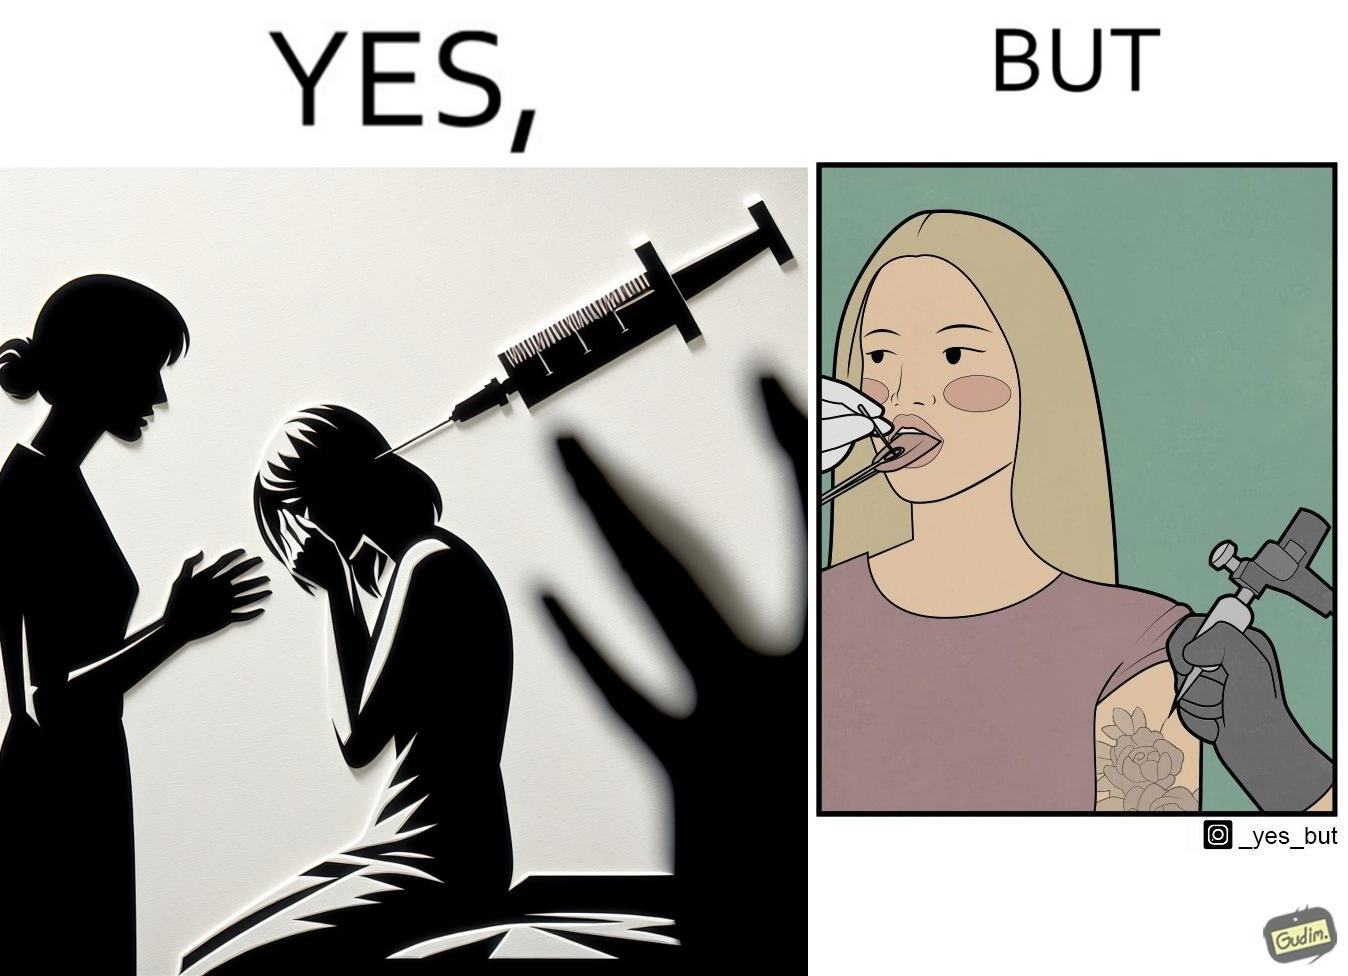Describe the satirical element in this image. The image is funny becuase while the woman is scared of getting an injection which is for her benefit, she is not afraid of getting a piercing or a tattoo which are not going to help her in any way. 